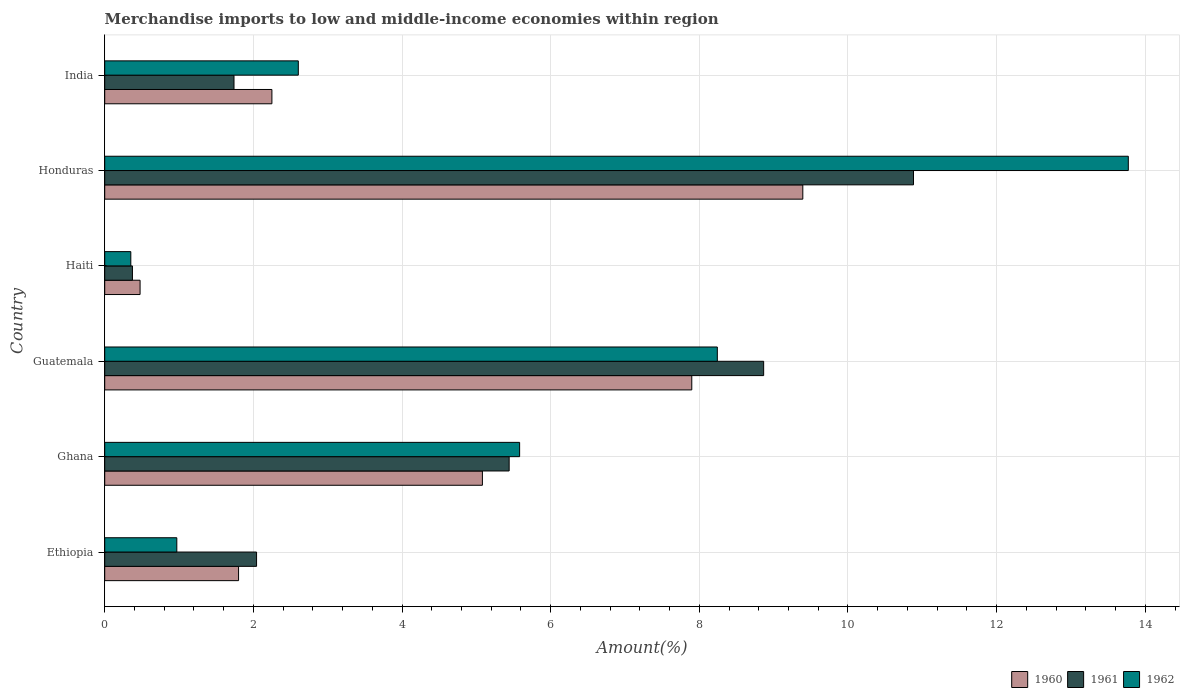How many different coloured bars are there?
Ensure brevity in your answer.  3. How many groups of bars are there?
Keep it short and to the point. 6. Are the number of bars on each tick of the Y-axis equal?
Ensure brevity in your answer.  Yes. What is the label of the 5th group of bars from the top?
Ensure brevity in your answer.  Ghana. In how many cases, is the number of bars for a given country not equal to the number of legend labels?
Your answer should be compact. 0. What is the percentage of amount earned from merchandise imports in 1962 in Ghana?
Your answer should be compact. 5.58. Across all countries, what is the maximum percentage of amount earned from merchandise imports in 1961?
Ensure brevity in your answer.  10.88. Across all countries, what is the minimum percentage of amount earned from merchandise imports in 1960?
Your response must be concise. 0.48. In which country was the percentage of amount earned from merchandise imports in 1962 maximum?
Make the answer very short. Honduras. In which country was the percentage of amount earned from merchandise imports in 1961 minimum?
Provide a succinct answer. Haiti. What is the total percentage of amount earned from merchandise imports in 1960 in the graph?
Your answer should be very brief. 26.9. What is the difference between the percentage of amount earned from merchandise imports in 1960 in Ethiopia and that in Haiti?
Your response must be concise. 1.33. What is the difference between the percentage of amount earned from merchandise imports in 1962 in Guatemala and the percentage of amount earned from merchandise imports in 1960 in Ethiopia?
Your answer should be compact. 6.44. What is the average percentage of amount earned from merchandise imports in 1962 per country?
Give a very brief answer. 5.25. What is the difference between the percentage of amount earned from merchandise imports in 1960 and percentage of amount earned from merchandise imports in 1962 in Ethiopia?
Make the answer very short. 0.83. What is the ratio of the percentage of amount earned from merchandise imports in 1962 in Ethiopia to that in India?
Provide a succinct answer. 0.37. What is the difference between the highest and the second highest percentage of amount earned from merchandise imports in 1962?
Your answer should be very brief. 5.53. What is the difference between the highest and the lowest percentage of amount earned from merchandise imports in 1961?
Your answer should be compact. 10.51. Is the sum of the percentage of amount earned from merchandise imports in 1962 in Ethiopia and Haiti greater than the maximum percentage of amount earned from merchandise imports in 1960 across all countries?
Ensure brevity in your answer.  No. What does the 1st bar from the bottom in Guatemala represents?
Make the answer very short. 1960. Are all the bars in the graph horizontal?
Your response must be concise. Yes. How many countries are there in the graph?
Provide a succinct answer. 6. Are the values on the major ticks of X-axis written in scientific E-notation?
Ensure brevity in your answer.  No. Does the graph contain any zero values?
Keep it short and to the point. No. Where does the legend appear in the graph?
Provide a succinct answer. Bottom right. How many legend labels are there?
Give a very brief answer. 3. How are the legend labels stacked?
Your response must be concise. Horizontal. What is the title of the graph?
Offer a terse response. Merchandise imports to low and middle-income economies within region. Does "1975" appear as one of the legend labels in the graph?
Your response must be concise. No. What is the label or title of the X-axis?
Your response must be concise. Amount(%). What is the Amount(%) of 1960 in Ethiopia?
Keep it short and to the point. 1.8. What is the Amount(%) of 1961 in Ethiopia?
Your response must be concise. 2.04. What is the Amount(%) of 1962 in Ethiopia?
Your answer should be compact. 0.97. What is the Amount(%) in 1960 in Ghana?
Make the answer very short. 5.08. What is the Amount(%) in 1961 in Ghana?
Provide a short and direct response. 5.44. What is the Amount(%) of 1962 in Ghana?
Your answer should be very brief. 5.58. What is the Amount(%) of 1960 in Guatemala?
Provide a succinct answer. 7.9. What is the Amount(%) in 1961 in Guatemala?
Your response must be concise. 8.87. What is the Amount(%) of 1962 in Guatemala?
Offer a very short reply. 8.24. What is the Amount(%) in 1960 in Haiti?
Give a very brief answer. 0.48. What is the Amount(%) in 1961 in Haiti?
Make the answer very short. 0.37. What is the Amount(%) of 1962 in Haiti?
Your response must be concise. 0.35. What is the Amount(%) in 1960 in Honduras?
Provide a succinct answer. 9.39. What is the Amount(%) in 1961 in Honduras?
Your response must be concise. 10.88. What is the Amount(%) in 1962 in Honduras?
Provide a succinct answer. 13.77. What is the Amount(%) in 1960 in India?
Offer a terse response. 2.25. What is the Amount(%) in 1961 in India?
Provide a succinct answer. 1.74. What is the Amount(%) of 1962 in India?
Provide a short and direct response. 2.6. Across all countries, what is the maximum Amount(%) of 1960?
Offer a very short reply. 9.39. Across all countries, what is the maximum Amount(%) in 1961?
Your answer should be very brief. 10.88. Across all countries, what is the maximum Amount(%) in 1962?
Keep it short and to the point. 13.77. Across all countries, what is the minimum Amount(%) of 1960?
Keep it short and to the point. 0.48. Across all countries, what is the minimum Amount(%) of 1961?
Ensure brevity in your answer.  0.37. Across all countries, what is the minimum Amount(%) of 1962?
Provide a short and direct response. 0.35. What is the total Amount(%) in 1960 in the graph?
Ensure brevity in your answer.  26.9. What is the total Amount(%) of 1961 in the graph?
Offer a very short reply. 29.34. What is the total Amount(%) of 1962 in the graph?
Your answer should be very brief. 31.52. What is the difference between the Amount(%) of 1960 in Ethiopia and that in Ghana?
Offer a terse response. -3.28. What is the difference between the Amount(%) of 1961 in Ethiopia and that in Ghana?
Offer a terse response. -3.4. What is the difference between the Amount(%) in 1962 in Ethiopia and that in Ghana?
Offer a very short reply. -4.61. What is the difference between the Amount(%) of 1960 in Ethiopia and that in Guatemala?
Your response must be concise. -6.1. What is the difference between the Amount(%) in 1961 in Ethiopia and that in Guatemala?
Ensure brevity in your answer.  -6.82. What is the difference between the Amount(%) of 1962 in Ethiopia and that in Guatemala?
Your answer should be very brief. -7.27. What is the difference between the Amount(%) in 1960 in Ethiopia and that in Haiti?
Provide a succinct answer. 1.33. What is the difference between the Amount(%) in 1961 in Ethiopia and that in Haiti?
Your answer should be compact. 1.67. What is the difference between the Amount(%) of 1962 in Ethiopia and that in Haiti?
Ensure brevity in your answer.  0.62. What is the difference between the Amount(%) of 1960 in Ethiopia and that in Honduras?
Offer a very short reply. -7.59. What is the difference between the Amount(%) of 1961 in Ethiopia and that in Honduras?
Provide a succinct answer. -8.84. What is the difference between the Amount(%) in 1962 in Ethiopia and that in Honduras?
Your answer should be very brief. -12.8. What is the difference between the Amount(%) of 1960 in Ethiopia and that in India?
Ensure brevity in your answer.  -0.45. What is the difference between the Amount(%) in 1961 in Ethiopia and that in India?
Provide a succinct answer. 0.3. What is the difference between the Amount(%) of 1962 in Ethiopia and that in India?
Keep it short and to the point. -1.63. What is the difference between the Amount(%) of 1960 in Ghana and that in Guatemala?
Your answer should be very brief. -2.82. What is the difference between the Amount(%) in 1961 in Ghana and that in Guatemala?
Offer a terse response. -3.42. What is the difference between the Amount(%) in 1962 in Ghana and that in Guatemala?
Provide a succinct answer. -2.66. What is the difference between the Amount(%) of 1960 in Ghana and that in Haiti?
Your answer should be very brief. 4.61. What is the difference between the Amount(%) in 1961 in Ghana and that in Haiti?
Provide a short and direct response. 5.07. What is the difference between the Amount(%) of 1962 in Ghana and that in Haiti?
Provide a short and direct response. 5.23. What is the difference between the Amount(%) of 1960 in Ghana and that in Honduras?
Offer a terse response. -4.31. What is the difference between the Amount(%) of 1961 in Ghana and that in Honduras?
Provide a succinct answer. -5.44. What is the difference between the Amount(%) of 1962 in Ghana and that in Honduras?
Keep it short and to the point. -8.19. What is the difference between the Amount(%) of 1960 in Ghana and that in India?
Provide a succinct answer. 2.83. What is the difference between the Amount(%) in 1961 in Ghana and that in India?
Offer a terse response. 3.7. What is the difference between the Amount(%) in 1962 in Ghana and that in India?
Give a very brief answer. 2.98. What is the difference between the Amount(%) of 1960 in Guatemala and that in Haiti?
Offer a very short reply. 7.42. What is the difference between the Amount(%) of 1961 in Guatemala and that in Haiti?
Ensure brevity in your answer.  8.49. What is the difference between the Amount(%) in 1962 in Guatemala and that in Haiti?
Offer a terse response. 7.89. What is the difference between the Amount(%) of 1960 in Guatemala and that in Honduras?
Keep it short and to the point. -1.49. What is the difference between the Amount(%) in 1961 in Guatemala and that in Honduras?
Keep it short and to the point. -2.02. What is the difference between the Amount(%) in 1962 in Guatemala and that in Honduras?
Provide a short and direct response. -5.53. What is the difference between the Amount(%) of 1960 in Guatemala and that in India?
Keep it short and to the point. 5.65. What is the difference between the Amount(%) of 1961 in Guatemala and that in India?
Offer a terse response. 7.13. What is the difference between the Amount(%) of 1962 in Guatemala and that in India?
Offer a very short reply. 5.64. What is the difference between the Amount(%) of 1960 in Haiti and that in Honduras?
Your response must be concise. -8.92. What is the difference between the Amount(%) in 1961 in Haiti and that in Honduras?
Your answer should be very brief. -10.51. What is the difference between the Amount(%) in 1962 in Haiti and that in Honduras?
Offer a terse response. -13.42. What is the difference between the Amount(%) in 1960 in Haiti and that in India?
Your answer should be very brief. -1.77. What is the difference between the Amount(%) in 1961 in Haiti and that in India?
Your answer should be compact. -1.37. What is the difference between the Amount(%) in 1962 in Haiti and that in India?
Your answer should be compact. -2.25. What is the difference between the Amount(%) of 1960 in Honduras and that in India?
Provide a succinct answer. 7.14. What is the difference between the Amount(%) in 1961 in Honduras and that in India?
Ensure brevity in your answer.  9.14. What is the difference between the Amount(%) of 1962 in Honduras and that in India?
Provide a short and direct response. 11.17. What is the difference between the Amount(%) of 1960 in Ethiopia and the Amount(%) of 1961 in Ghana?
Your response must be concise. -3.64. What is the difference between the Amount(%) in 1960 in Ethiopia and the Amount(%) in 1962 in Ghana?
Offer a very short reply. -3.78. What is the difference between the Amount(%) in 1961 in Ethiopia and the Amount(%) in 1962 in Ghana?
Provide a short and direct response. -3.54. What is the difference between the Amount(%) in 1960 in Ethiopia and the Amount(%) in 1961 in Guatemala?
Your answer should be compact. -7.06. What is the difference between the Amount(%) of 1960 in Ethiopia and the Amount(%) of 1962 in Guatemala?
Keep it short and to the point. -6.44. What is the difference between the Amount(%) of 1961 in Ethiopia and the Amount(%) of 1962 in Guatemala?
Offer a very short reply. -6.2. What is the difference between the Amount(%) in 1960 in Ethiopia and the Amount(%) in 1961 in Haiti?
Your response must be concise. 1.43. What is the difference between the Amount(%) of 1960 in Ethiopia and the Amount(%) of 1962 in Haiti?
Make the answer very short. 1.45. What is the difference between the Amount(%) in 1961 in Ethiopia and the Amount(%) in 1962 in Haiti?
Offer a very short reply. 1.69. What is the difference between the Amount(%) of 1960 in Ethiopia and the Amount(%) of 1961 in Honduras?
Keep it short and to the point. -9.08. What is the difference between the Amount(%) in 1960 in Ethiopia and the Amount(%) in 1962 in Honduras?
Your answer should be very brief. -11.97. What is the difference between the Amount(%) of 1961 in Ethiopia and the Amount(%) of 1962 in Honduras?
Give a very brief answer. -11.73. What is the difference between the Amount(%) in 1960 in Ethiopia and the Amount(%) in 1961 in India?
Provide a short and direct response. 0.06. What is the difference between the Amount(%) of 1960 in Ethiopia and the Amount(%) of 1962 in India?
Your answer should be very brief. -0.8. What is the difference between the Amount(%) in 1961 in Ethiopia and the Amount(%) in 1962 in India?
Give a very brief answer. -0.56. What is the difference between the Amount(%) in 1960 in Ghana and the Amount(%) in 1961 in Guatemala?
Offer a terse response. -3.78. What is the difference between the Amount(%) in 1960 in Ghana and the Amount(%) in 1962 in Guatemala?
Your response must be concise. -3.16. What is the difference between the Amount(%) in 1961 in Ghana and the Amount(%) in 1962 in Guatemala?
Your answer should be compact. -2.8. What is the difference between the Amount(%) of 1960 in Ghana and the Amount(%) of 1961 in Haiti?
Keep it short and to the point. 4.71. What is the difference between the Amount(%) of 1960 in Ghana and the Amount(%) of 1962 in Haiti?
Your response must be concise. 4.73. What is the difference between the Amount(%) in 1961 in Ghana and the Amount(%) in 1962 in Haiti?
Give a very brief answer. 5.09. What is the difference between the Amount(%) in 1960 in Ghana and the Amount(%) in 1961 in Honduras?
Provide a short and direct response. -5.8. What is the difference between the Amount(%) in 1960 in Ghana and the Amount(%) in 1962 in Honduras?
Provide a short and direct response. -8.69. What is the difference between the Amount(%) in 1961 in Ghana and the Amount(%) in 1962 in Honduras?
Provide a short and direct response. -8.33. What is the difference between the Amount(%) of 1960 in Ghana and the Amount(%) of 1961 in India?
Your response must be concise. 3.34. What is the difference between the Amount(%) of 1960 in Ghana and the Amount(%) of 1962 in India?
Your answer should be very brief. 2.48. What is the difference between the Amount(%) in 1961 in Ghana and the Amount(%) in 1962 in India?
Provide a succinct answer. 2.84. What is the difference between the Amount(%) of 1960 in Guatemala and the Amount(%) of 1961 in Haiti?
Ensure brevity in your answer.  7.53. What is the difference between the Amount(%) in 1960 in Guatemala and the Amount(%) in 1962 in Haiti?
Give a very brief answer. 7.55. What is the difference between the Amount(%) in 1961 in Guatemala and the Amount(%) in 1962 in Haiti?
Give a very brief answer. 8.51. What is the difference between the Amount(%) of 1960 in Guatemala and the Amount(%) of 1961 in Honduras?
Offer a terse response. -2.98. What is the difference between the Amount(%) of 1960 in Guatemala and the Amount(%) of 1962 in Honduras?
Provide a succinct answer. -5.87. What is the difference between the Amount(%) in 1961 in Guatemala and the Amount(%) in 1962 in Honduras?
Offer a terse response. -4.91. What is the difference between the Amount(%) of 1960 in Guatemala and the Amount(%) of 1961 in India?
Your response must be concise. 6.16. What is the difference between the Amount(%) of 1960 in Guatemala and the Amount(%) of 1962 in India?
Offer a terse response. 5.29. What is the difference between the Amount(%) of 1961 in Guatemala and the Amount(%) of 1962 in India?
Provide a succinct answer. 6.26. What is the difference between the Amount(%) of 1960 in Haiti and the Amount(%) of 1961 in Honduras?
Your response must be concise. -10.41. What is the difference between the Amount(%) in 1960 in Haiti and the Amount(%) in 1962 in Honduras?
Your response must be concise. -13.3. What is the difference between the Amount(%) in 1961 in Haiti and the Amount(%) in 1962 in Honduras?
Make the answer very short. -13.4. What is the difference between the Amount(%) of 1960 in Haiti and the Amount(%) of 1961 in India?
Offer a terse response. -1.26. What is the difference between the Amount(%) of 1960 in Haiti and the Amount(%) of 1962 in India?
Your answer should be compact. -2.13. What is the difference between the Amount(%) of 1961 in Haiti and the Amount(%) of 1962 in India?
Ensure brevity in your answer.  -2.23. What is the difference between the Amount(%) in 1960 in Honduras and the Amount(%) in 1961 in India?
Provide a short and direct response. 7.65. What is the difference between the Amount(%) of 1960 in Honduras and the Amount(%) of 1962 in India?
Give a very brief answer. 6.79. What is the difference between the Amount(%) in 1961 in Honduras and the Amount(%) in 1962 in India?
Provide a succinct answer. 8.28. What is the average Amount(%) in 1960 per country?
Ensure brevity in your answer.  4.48. What is the average Amount(%) in 1961 per country?
Provide a short and direct response. 4.89. What is the average Amount(%) of 1962 per country?
Your answer should be very brief. 5.25. What is the difference between the Amount(%) in 1960 and Amount(%) in 1961 in Ethiopia?
Provide a succinct answer. -0.24. What is the difference between the Amount(%) in 1960 and Amount(%) in 1962 in Ethiopia?
Provide a succinct answer. 0.83. What is the difference between the Amount(%) in 1961 and Amount(%) in 1962 in Ethiopia?
Give a very brief answer. 1.07. What is the difference between the Amount(%) of 1960 and Amount(%) of 1961 in Ghana?
Keep it short and to the point. -0.36. What is the difference between the Amount(%) in 1960 and Amount(%) in 1962 in Ghana?
Provide a succinct answer. -0.5. What is the difference between the Amount(%) of 1961 and Amount(%) of 1962 in Ghana?
Offer a terse response. -0.14. What is the difference between the Amount(%) in 1960 and Amount(%) in 1961 in Guatemala?
Give a very brief answer. -0.97. What is the difference between the Amount(%) in 1960 and Amount(%) in 1962 in Guatemala?
Give a very brief answer. -0.34. What is the difference between the Amount(%) of 1961 and Amount(%) of 1962 in Guatemala?
Make the answer very short. 0.62. What is the difference between the Amount(%) in 1960 and Amount(%) in 1961 in Haiti?
Provide a succinct answer. 0.1. What is the difference between the Amount(%) of 1960 and Amount(%) of 1962 in Haiti?
Your response must be concise. 0.12. What is the difference between the Amount(%) of 1961 and Amount(%) of 1962 in Haiti?
Offer a terse response. 0.02. What is the difference between the Amount(%) in 1960 and Amount(%) in 1961 in Honduras?
Ensure brevity in your answer.  -1.49. What is the difference between the Amount(%) in 1960 and Amount(%) in 1962 in Honduras?
Your response must be concise. -4.38. What is the difference between the Amount(%) of 1961 and Amount(%) of 1962 in Honduras?
Your response must be concise. -2.89. What is the difference between the Amount(%) in 1960 and Amount(%) in 1961 in India?
Your response must be concise. 0.51. What is the difference between the Amount(%) of 1960 and Amount(%) of 1962 in India?
Make the answer very short. -0.36. What is the difference between the Amount(%) in 1961 and Amount(%) in 1962 in India?
Ensure brevity in your answer.  -0.87. What is the ratio of the Amount(%) in 1960 in Ethiopia to that in Ghana?
Ensure brevity in your answer.  0.35. What is the ratio of the Amount(%) of 1961 in Ethiopia to that in Ghana?
Ensure brevity in your answer.  0.38. What is the ratio of the Amount(%) of 1962 in Ethiopia to that in Ghana?
Offer a terse response. 0.17. What is the ratio of the Amount(%) in 1960 in Ethiopia to that in Guatemala?
Offer a terse response. 0.23. What is the ratio of the Amount(%) in 1961 in Ethiopia to that in Guatemala?
Your answer should be compact. 0.23. What is the ratio of the Amount(%) of 1962 in Ethiopia to that in Guatemala?
Your answer should be compact. 0.12. What is the ratio of the Amount(%) in 1960 in Ethiopia to that in Haiti?
Provide a succinct answer. 3.79. What is the ratio of the Amount(%) in 1961 in Ethiopia to that in Haiti?
Your answer should be compact. 5.48. What is the ratio of the Amount(%) of 1962 in Ethiopia to that in Haiti?
Provide a short and direct response. 2.76. What is the ratio of the Amount(%) of 1960 in Ethiopia to that in Honduras?
Make the answer very short. 0.19. What is the ratio of the Amount(%) of 1961 in Ethiopia to that in Honduras?
Ensure brevity in your answer.  0.19. What is the ratio of the Amount(%) in 1962 in Ethiopia to that in Honduras?
Offer a very short reply. 0.07. What is the ratio of the Amount(%) of 1960 in Ethiopia to that in India?
Provide a succinct answer. 0.8. What is the ratio of the Amount(%) in 1961 in Ethiopia to that in India?
Your answer should be very brief. 1.17. What is the ratio of the Amount(%) in 1962 in Ethiopia to that in India?
Offer a terse response. 0.37. What is the ratio of the Amount(%) in 1960 in Ghana to that in Guatemala?
Your response must be concise. 0.64. What is the ratio of the Amount(%) in 1961 in Ghana to that in Guatemala?
Your response must be concise. 0.61. What is the ratio of the Amount(%) in 1962 in Ghana to that in Guatemala?
Make the answer very short. 0.68. What is the ratio of the Amount(%) in 1960 in Ghana to that in Haiti?
Ensure brevity in your answer.  10.68. What is the ratio of the Amount(%) of 1961 in Ghana to that in Haiti?
Your answer should be very brief. 14.59. What is the ratio of the Amount(%) of 1962 in Ghana to that in Haiti?
Your response must be concise. 15.9. What is the ratio of the Amount(%) in 1960 in Ghana to that in Honduras?
Ensure brevity in your answer.  0.54. What is the ratio of the Amount(%) of 1961 in Ghana to that in Honduras?
Give a very brief answer. 0.5. What is the ratio of the Amount(%) of 1962 in Ghana to that in Honduras?
Your answer should be very brief. 0.41. What is the ratio of the Amount(%) in 1960 in Ghana to that in India?
Offer a very short reply. 2.26. What is the ratio of the Amount(%) of 1961 in Ghana to that in India?
Keep it short and to the point. 3.13. What is the ratio of the Amount(%) in 1962 in Ghana to that in India?
Offer a terse response. 2.14. What is the ratio of the Amount(%) in 1960 in Guatemala to that in Haiti?
Provide a short and direct response. 16.61. What is the ratio of the Amount(%) in 1961 in Guatemala to that in Haiti?
Offer a terse response. 23.77. What is the ratio of the Amount(%) in 1962 in Guatemala to that in Haiti?
Give a very brief answer. 23.47. What is the ratio of the Amount(%) of 1960 in Guatemala to that in Honduras?
Ensure brevity in your answer.  0.84. What is the ratio of the Amount(%) in 1961 in Guatemala to that in Honduras?
Provide a short and direct response. 0.81. What is the ratio of the Amount(%) of 1962 in Guatemala to that in Honduras?
Ensure brevity in your answer.  0.6. What is the ratio of the Amount(%) of 1960 in Guatemala to that in India?
Ensure brevity in your answer.  3.51. What is the ratio of the Amount(%) in 1961 in Guatemala to that in India?
Provide a short and direct response. 5.1. What is the ratio of the Amount(%) of 1962 in Guatemala to that in India?
Keep it short and to the point. 3.16. What is the ratio of the Amount(%) of 1960 in Haiti to that in Honduras?
Keep it short and to the point. 0.05. What is the ratio of the Amount(%) of 1961 in Haiti to that in Honduras?
Ensure brevity in your answer.  0.03. What is the ratio of the Amount(%) of 1962 in Haiti to that in Honduras?
Offer a very short reply. 0.03. What is the ratio of the Amount(%) in 1960 in Haiti to that in India?
Offer a very short reply. 0.21. What is the ratio of the Amount(%) in 1961 in Haiti to that in India?
Your response must be concise. 0.21. What is the ratio of the Amount(%) in 1962 in Haiti to that in India?
Provide a short and direct response. 0.13. What is the ratio of the Amount(%) in 1960 in Honduras to that in India?
Your answer should be very brief. 4.18. What is the ratio of the Amount(%) in 1961 in Honduras to that in India?
Offer a terse response. 6.26. What is the ratio of the Amount(%) in 1962 in Honduras to that in India?
Your response must be concise. 5.29. What is the difference between the highest and the second highest Amount(%) in 1960?
Give a very brief answer. 1.49. What is the difference between the highest and the second highest Amount(%) of 1961?
Ensure brevity in your answer.  2.02. What is the difference between the highest and the second highest Amount(%) of 1962?
Your answer should be compact. 5.53. What is the difference between the highest and the lowest Amount(%) of 1960?
Offer a very short reply. 8.92. What is the difference between the highest and the lowest Amount(%) of 1961?
Offer a very short reply. 10.51. What is the difference between the highest and the lowest Amount(%) in 1962?
Your response must be concise. 13.42. 